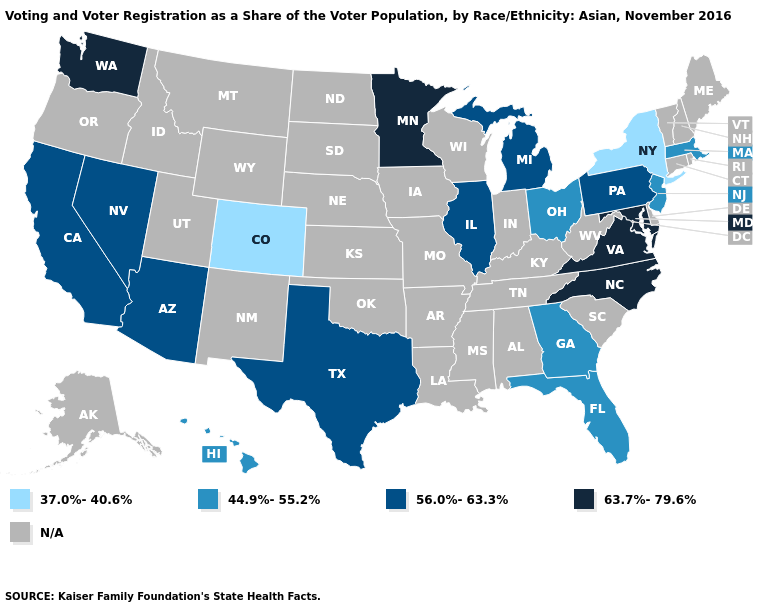What is the highest value in the West ?
Answer briefly. 63.7%-79.6%. What is the lowest value in the South?
Short answer required. 44.9%-55.2%. Does New Jersey have the lowest value in the USA?
Concise answer only. No. Name the states that have a value in the range 63.7%-79.6%?
Quick response, please. Maryland, Minnesota, North Carolina, Virginia, Washington. Name the states that have a value in the range N/A?
Concise answer only. Alabama, Alaska, Arkansas, Connecticut, Delaware, Idaho, Indiana, Iowa, Kansas, Kentucky, Louisiana, Maine, Mississippi, Missouri, Montana, Nebraska, New Hampshire, New Mexico, North Dakota, Oklahoma, Oregon, Rhode Island, South Carolina, South Dakota, Tennessee, Utah, Vermont, West Virginia, Wisconsin, Wyoming. What is the value of Louisiana?
Concise answer only. N/A. Does Georgia have the highest value in the South?
Short answer required. No. What is the value of New York?
Short answer required. 37.0%-40.6%. What is the highest value in states that border Connecticut?
Be succinct. 44.9%-55.2%. What is the highest value in the South ?
Give a very brief answer. 63.7%-79.6%. 